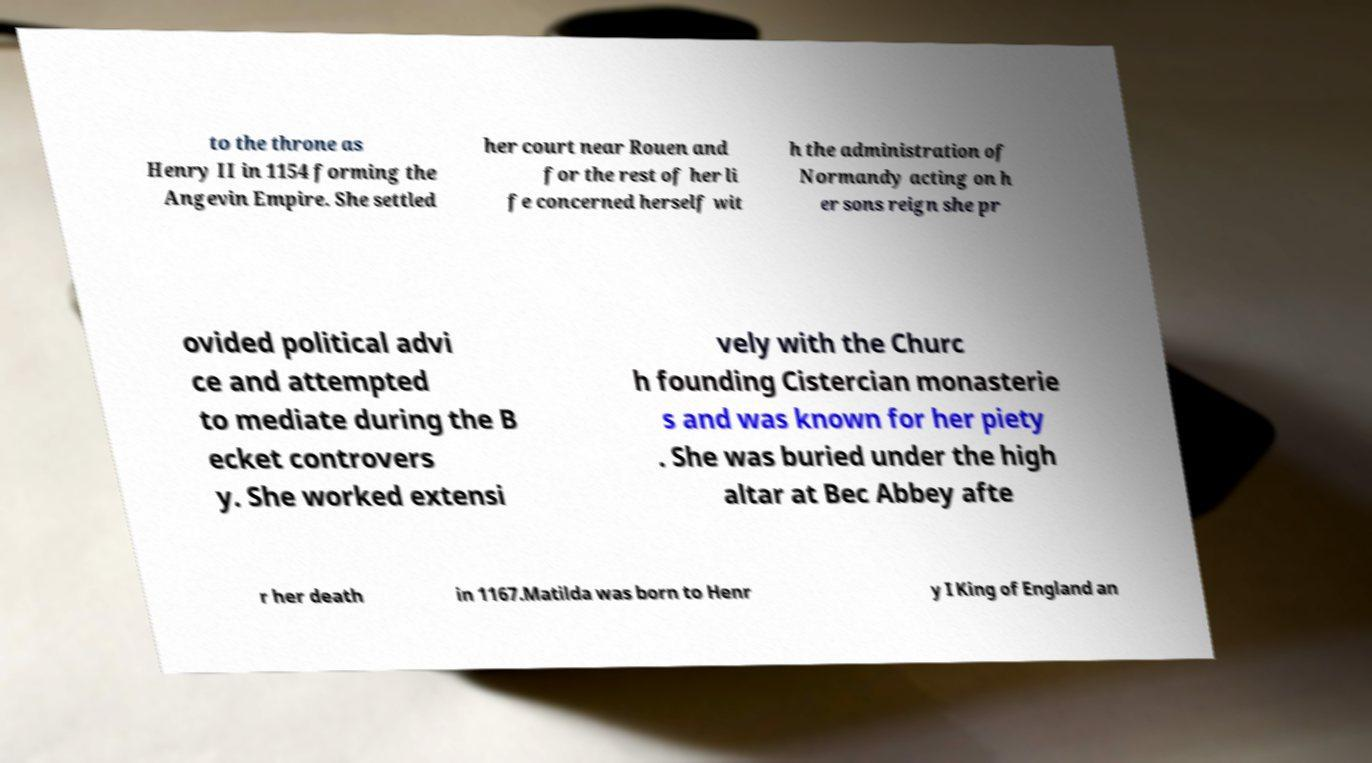I need the written content from this picture converted into text. Can you do that? to the throne as Henry II in 1154 forming the Angevin Empire. She settled her court near Rouen and for the rest of her li fe concerned herself wit h the administration of Normandy acting on h er sons reign she pr ovided political advi ce and attempted to mediate during the B ecket controvers y. She worked extensi vely with the Churc h founding Cistercian monasterie s and was known for her piety . She was buried under the high altar at Bec Abbey afte r her death in 1167.Matilda was born to Henr y I King of England an 